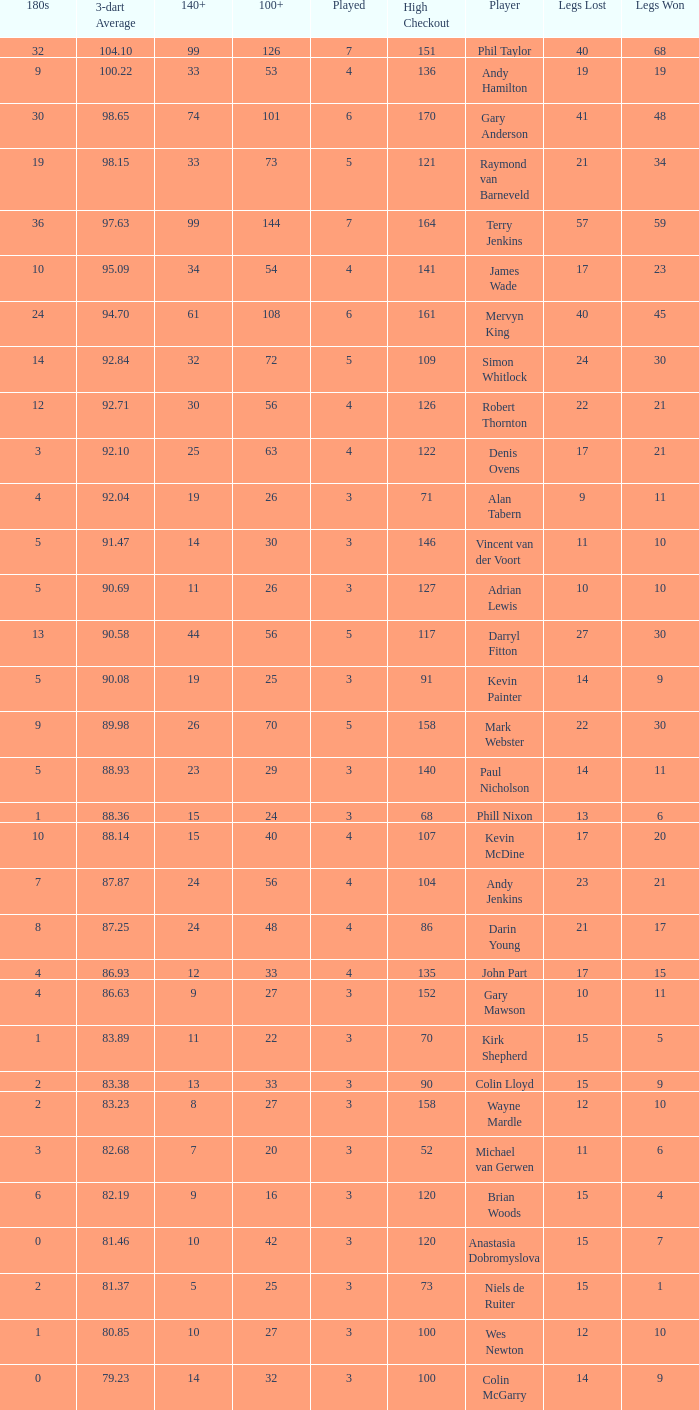What is the highest Legs Lost with a 180s larger than 1, a 100+ of 53, and played is smaller than 4? None. 